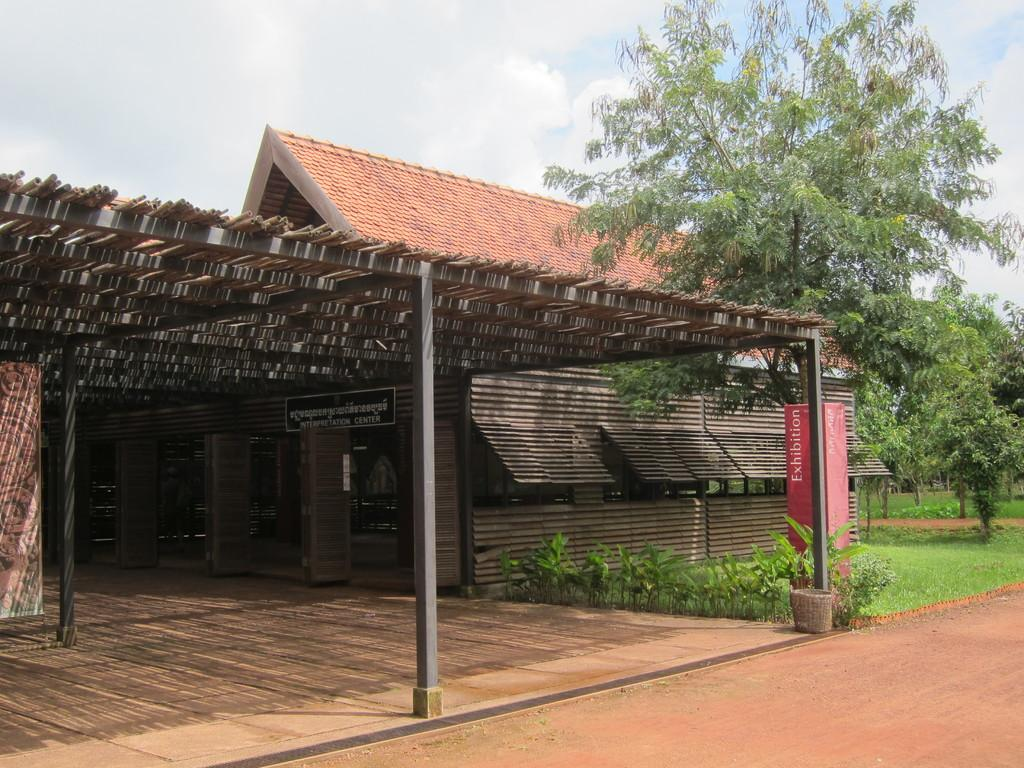What type of structure is visible in the image? There is a house in the image. Is there any identification for the house? Yes, there is a name board in the image. What architectural features can be seen in the image? There are pillars visible in the image. What type of vegetation is present in the image? There are plants, trees, and grass in the image. Is there a path in the image? Yes, there is a path in the image. What can be seen in the background of the image? The sky with clouds is visible in the background of the image. How does the goose breathe in the image? There is no goose present in the image, so it is not possible to determine how it would breathe. 